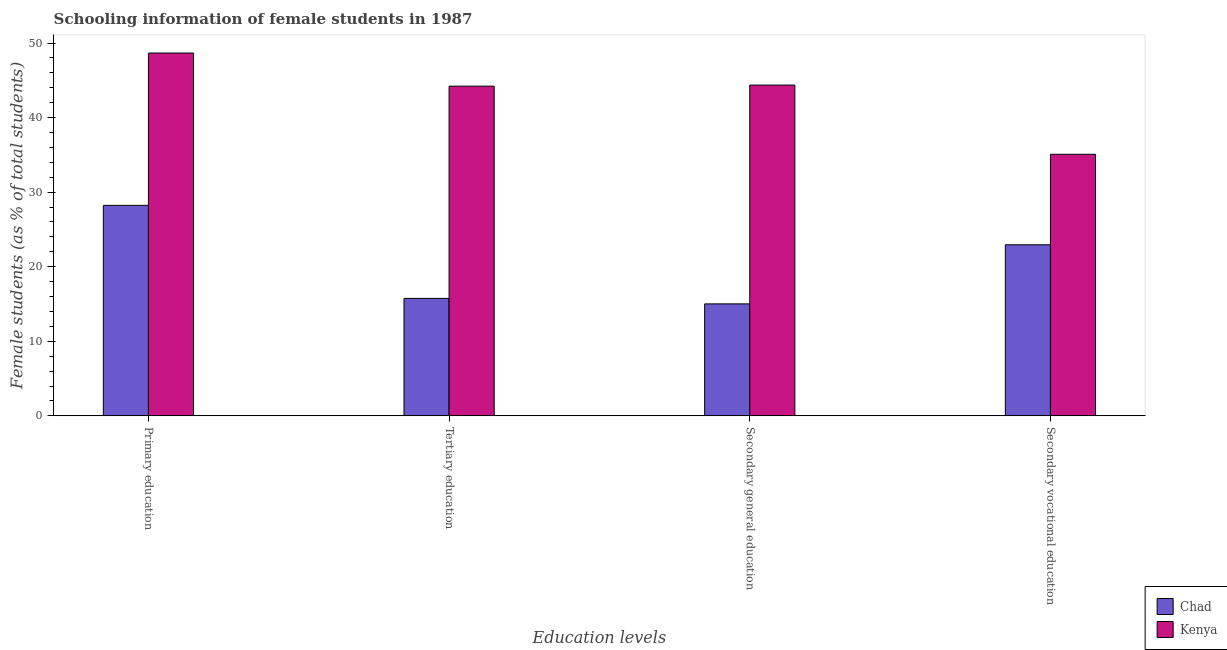How many different coloured bars are there?
Give a very brief answer. 2. How many groups of bars are there?
Keep it short and to the point. 4. Are the number of bars per tick equal to the number of legend labels?
Offer a very short reply. Yes. Are the number of bars on each tick of the X-axis equal?
Give a very brief answer. Yes. What is the percentage of female students in secondary education in Chad?
Your answer should be very brief. 15.02. Across all countries, what is the maximum percentage of female students in secondary education?
Provide a short and direct response. 44.36. Across all countries, what is the minimum percentage of female students in tertiary education?
Offer a very short reply. 15.75. In which country was the percentage of female students in tertiary education maximum?
Make the answer very short. Kenya. In which country was the percentage of female students in tertiary education minimum?
Make the answer very short. Chad. What is the total percentage of female students in primary education in the graph?
Provide a short and direct response. 76.89. What is the difference between the percentage of female students in secondary education in Kenya and that in Chad?
Ensure brevity in your answer.  29.35. What is the difference between the percentage of female students in secondary education in Chad and the percentage of female students in secondary vocational education in Kenya?
Your answer should be compact. -20.06. What is the average percentage of female students in secondary vocational education per country?
Offer a terse response. 29.01. What is the difference between the percentage of female students in primary education and percentage of female students in secondary vocational education in Kenya?
Provide a succinct answer. 13.58. What is the ratio of the percentage of female students in secondary education in Chad to that in Kenya?
Your answer should be very brief. 0.34. What is the difference between the highest and the second highest percentage of female students in primary education?
Your answer should be compact. 20.43. What is the difference between the highest and the lowest percentage of female students in tertiary education?
Provide a short and direct response. 28.46. In how many countries, is the percentage of female students in secondary education greater than the average percentage of female students in secondary education taken over all countries?
Offer a terse response. 1. Is it the case that in every country, the sum of the percentage of female students in primary education and percentage of female students in secondary vocational education is greater than the sum of percentage of female students in tertiary education and percentage of female students in secondary education?
Provide a short and direct response. No. What does the 2nd bar from the left in Secondary general education represents?
Your response must be concise. Kenya. What does the 1st bar from the right in Primary education represents?
Offer a terse response. Kenya. Is it the case that in every country, the sum of the percentage of female students in primary education and percentage of female students in tertiary education is greater than the percentage of female students in secondary education?
Keep it short and to the point. Yes. How many bars are there?
Offer a very short reply. 8. How many countries are there in the graph?
Provide a succinct answer. 2. Does the graph contain any zero values?
Offer a terse response. No. How are the legend labels stacked?
Ensure brevity in your answer.  Vertical. What is the title of the graph?
Your response must be concise. Schooling information of female students in 1987. What is the label or title of the X-axis?
Make the answer very short. Education levels. What is the label or title of the Y-axis?
Provide a short and direct response. Female students (as % of total students). What is the Female students (as % of total students) in Chad in Primary education?
Your answer should be very brief. 28.23. What is the Female students (as % of total students) of Kenya in Primary education?
Your answer should be very brief. 48.66. What is the Female students (as % of total students) in Chad in Tertiary education?
Provide a succinct answer. 15.75. What is the Female students (as % of total students) in Kenya in Tertiary education?
Offer a terse response. 44.22. What is the Female students (as % of total students) in Chad in Secondary general education?
Keep it short and to the point. 15.02. What is the Female students (as % of total students) of Kenya in Secondary general education?
Your answer should be compact. 44.36. What is the Female students (as % of total students) in Chad in Secondary vocational education?
Give a very brief answer. 22.94. What is the Female students (as % of total students) in Kenya in Secondary vocational education?
Your response must be concise. 35.08. Across all Education levels, what is the maximum Female students (as % of total students) of Chad?
Offer a terse response. 28.23. Across all Education levels, what is the maximum Female students (as % of total students) of Kenya?
Provide a short and direct response. 48.66. Across all Education levels, what is the minimum Female students (as % of total students) of Chad?
Provide a short and direct response. 15.02. Across all Education levels, what is the minimum Female students (as % of total students) in Kenya?
Offer a very short reply. 35.08. What is the total Female students (as % of total students) of Chad in the graph?
Keep it short and to the point. 81.94. What is the total Female students (as % of total students) in Kenya in the graph?
Provide a succinct answer. 172.32. What is the difference between the Female students (as % of total students) of Chad in Primary education and that in Tertiary education?
Keep it short and to the point. 12.48. What is the difference between the Female students (as % of total students) in Kenya in Primary education and that in Tertiary education?
Offer a very short reply. 4.44. What is the difference between the Female students (as % of total students) of Chad in Primary education and that in Secondary general education?
Provide a short and direct response. 13.21. What is the difference between the Female students (as % of total students) of Kenya in Primary education and that in Secondary general education?
Make the answer very short. 4.3. What is the difference between the Female students (as % of total students) of Chad in Primary education and that in Secondary vocational education?
Your answer should be very brief. 5.29. What is the difference between the Female students (as % of total students) of Kenya in Primary education and that in Secondary vocational education?
Offer a very short reply. 13.58. What is the difference between the Female students (as % of total students) of Chad in Tertiary education and that in Secondary general education?
Offer a very short reply. 0.74. What is the difference between the Female students (as % of total students) of Kenya in Tertiary education and that in Secondary general education?
Your answer should be compact. -0.15. What is the difference between the Female students (as % of total students) of Chad in Tertiary education and that in Secondary vocational education?
Your response must be concise. -7.19. What is the difference between the Female students (as % of total students) in Kenya in Tertiary education and that in Secondary vocational education?
Provide a short and direct response. 9.14. What is the difference between the Female students (as % of total students) of Chad in Secondary general education and that in Secondary vocational education?
Provide a short and direct response. -7.93. What is the difference between the Female students (as % of total students) in Kenya in Secondary general education and that in Secondary vocational education?
Your answer should be compact. 9.28. What is the difference between the Female students (as % of total students) in Chad in Primary education and the Female students (as % of total students) in Kenya in Tertiary education?
Offer a very short reply. -15.99. What is the difference between the Female students (as % of total students) of Chad in Primary education and the Female students (as % of total students) of Kenya in Secondary general education?
Offer a terse response. -16.13. What is the difference between the Female students (as % of total students) in Chad in Primary education and the Female students (as % of total students) in Kenya in Secondary vocational education?
Give a very brief answer. -6.85. What is the difference between the Female students (as % of total students) in Chad in Tertiary education and the Female students (as % of total students) in Kenya in Secondary general education?
Give a very brief answer. -28.61. What is the difference between the Female students (as % of total students) in Chad in Tertiary education and the Female students (as % of total students) in Kenya in Secondary vocational education?
Provide a succinct answer. -19.33. What is the difference between the Female students (as % of total students) in Chad in Secondary general education and the Female students (as % of total students) in Kenya in Secondary vocational education?
Your response must be concise. -20.06. What is the average Female students (as % of total students) in Chad per Education levels?
Provide a short and direct response. 20.49. What is the average Female students (as % of total students) of Kenya per Education levels?
Your answer should be very brief. 43.08. What is the difference between the Female students (as % of total students) in Chad and Female students (as % of total students) in Kenya in Primary education?
Keep it short and to the point. -20.43. What is the difference between the Female students (as % of total students) in Chad and Female students (as % of total students) in Kenya in Tertiary education?
Your response must be concise. -28.46. What is the difference between the Female students (as % of total students) of Chad and Female students (as % of total students) of Kenya in Secondary general education?
Your response must be concise. -29.35. What is the difference between the Female students (as % of total students) in Chad and Female students (as % of total students) in Kenya in Secondary vocational education?
Offer a very short reply. -12.14. What is the ratio of the Female students (as % of total students) in Chad in Primary education to that in Tertiary education?
Your answer should be compact. 1.79. What is the ratio of the Female students (as % of total students) of Kenya in Primary education to that in Tertiary education?
Your response must be concise. 1.1. What is the ratio of the Female students (as % of total students) of Chad in Primary education to that in Secondary general education?
Make the answer very short. 1.88. What is the ratio of the Female students (as % of total students) of Kenya in Primary education to that in Secondary general education?
Your answer should be very brief. 1.1. What is the ratio of the Female students (as % of total students) of Chad in Primary education to that in Secondary vocational education?
Offer a very short reply. 1.23. What is the ratio of the Female students (as % of total students) of Kenya in Primary education to that in Secondary vocational education?
Your answer should be very brief. 1.39. What is the ratio of the Female students (as % of total students) in Chad in Tertiary education to that in Secondary general education?
Give a very brief answer. 1.05. What is the ratio of the Female students (as % of total students) of Chad in Tertiary education to that in Secondary vocational education?
Give a very brief answer. 0.69. What is the ratio of the Female students (as % of total students) in Kenya in Tertiary education to that in Secondary vocational education?
Offer a very short reply. 1.26. What is the ratio of the Female students (as % of total students) of Chad in Secondary general education to that in Secondary vocational education?
Your answer should be very brief. 0.65. What is the ratio of the Female students (as % of total students) in Kenya in Secondary general education to that in Secondary vocational education?
Provide a short and direct response. 1.26. What is the difference between the highest and the second highest Female students (as % of total students) in Chad?
Your answer should be very brief. 5.29. What is the difference between the highest and the second highest Female students (as % of total students) in Kenya?
Ensure brevity in your answer.  4.3. What is the difference between the highest and the lowest Female students (as % of total students) in Chad?
Make the answer very short. 13.21. What is the difference between the highest and the lowest Female students (as % of total students) of Kenya?
Your answer should be very brief. 13.58. 